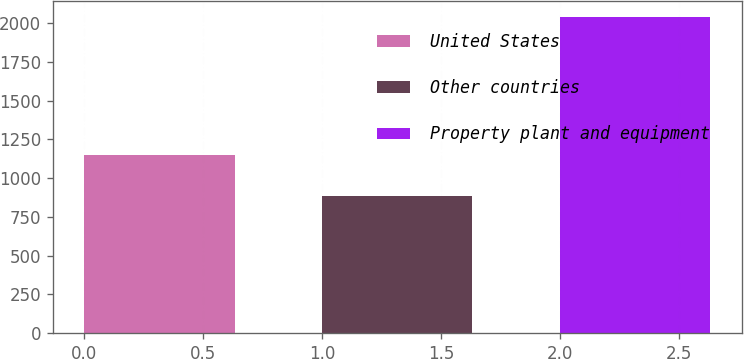Convert chart. <chart><loc_0><loc_0><loc_500><loc_500><bar_chart><fcel>United States<fcel>Other countries<fcel>Property plant and equipment<nl><fcel>1151.6<fcel>887<fcel>2038.6<nl></chart> 